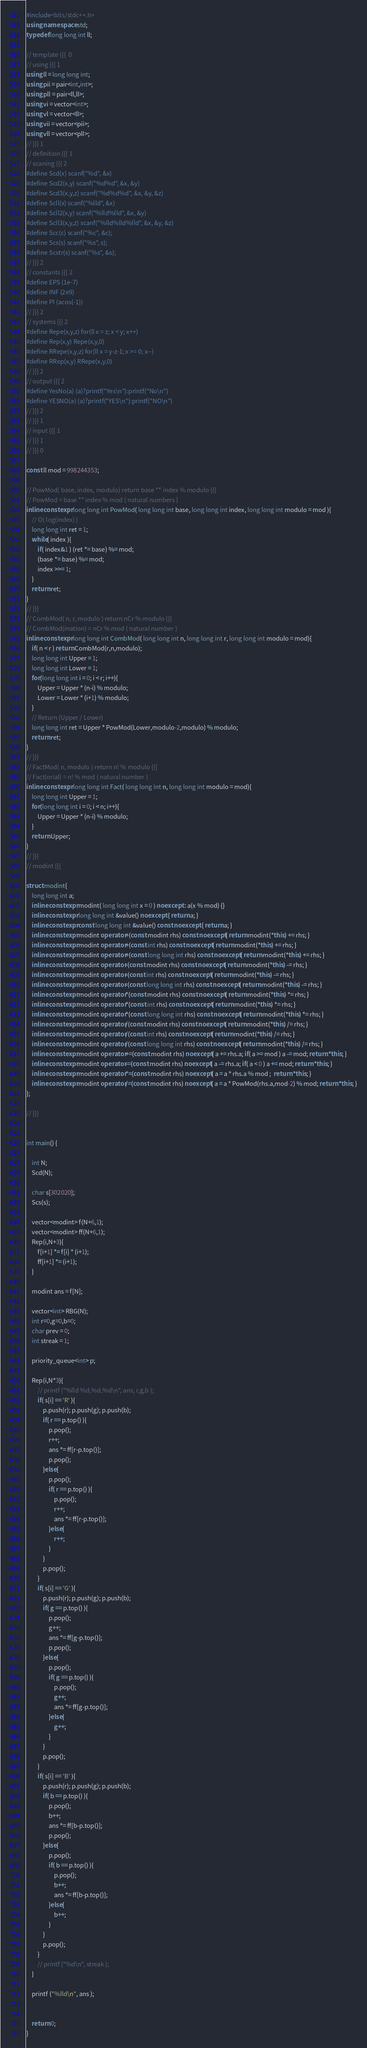Convert code to text. <code><loc_0><loc_0><loc_500><loc_500><_C++_>#include<bits/stdc++.h>
using namespace std;
typedef long long int ll;

// template {{{  0 
// using {{{ 1
using ll = long long int;
using pii = pair<int,int>;
using pll = pair<ll,ll>;
using vi = vector<int>;
using vl = vector<ll>;
using vii = vector<pii>;
using vll = vector<pll>;
// }}} 1
// definition {{{ 1
// scaning {{{ 2
#define Scd(x) scanf("%d", &x)
#define Scd2(x,y) scanf("%d%d", &x, &y)
#define Scd3(x,y,z) scanf("%d%d%d", &x, &y, &z)
#define Scll(x) scanf("%lld", &x)
#define Scll2(x,y) scanf("%lld%lld", &x, &y)
#define Scll3(x,y,z) scanf("%lld%lld%lld", &x, &y, &z)
#define Scc(c) scanf("%c", &c);
#define Scs(s) scanf("%s", s);
#define Scstr(s) scanf("%s", &s);
// }}} 2
// constants {{{ 2
#define EPS (1e-7)
#define INF (2e9)
#define PI (acos(-1))
// }}} 2
// systems {{{ 2
#define Repe(x,y,z) for(ll x = z; x < y; x++)
#define Rep(x,y) Repe(x,y,0)
#define RRepe(x,y,z) for(ll x = y-z-1; x >= 0; x--)
#define RRep(x,y) RRepe(x,y,0)
// }}} 2
// output {{{ 2
#define YesNo(a) (a)?printf("Yes\n"):printf("No\n")
#define YESNO(a) (a)?printf("YES\n"):printf("NO\n")
// }}} 2
// }}} 1
// input {{{ 1
// }}} 1
// }}} 0

const ll mod = 998244353;

// PowMod( base, index, modulo) return base ** index % modulo {{{
// PowMod = base ** index % mod ( natural numbers )
inline constexpr long long int PowMod( long long int base, long long int index, long long int modulo = mod ){
    // O( log(index) )
    long long int ret = 1;
    while( index ){
        if( index&1 ) (ret *= base) %= mod;
        (base *= base) %= mod;
        index >>= 1;
    }
    return ret;
}
// }}}
// CombMod( n, r, modulo ) return nCr % modulo {{{
// CombMod(ination) = nCr % mod ( natural number )
inline constexpr long long int CombMod( long long int n, long long int r, long long int modulo = mod){
    if( n < r ) return CombMod(r,n,modulo);
    long long int Upper = 1;
    long long int Lower = 1;
    for(long long int i = 0; i < r; i++){
        Upper = Upper * (n-i) % modulo;
        Lower = Lower * (i+1) % modulo;
    }
    // Return (Upper / Lower)
    long long int ret = Upper * PowMod(Lower,modulo-2,modulo) % modulo;
    return ret;
}
// }}}
// FactMod( n, modulo ) return n! % modulo {{{
// Fact(orial) = n! % mod ( natural number )
inline constexpr long long int Fact( long long int n, long long int modulo = mod){
    long long int Upper = 1;
    for(long long int i = 0; i < n; i++){
        Upper = Upper * (n-i) % modulo;
    }
    return Upper;
}
// }}}
// modint {{{

struct modint{
    long long int a;
    inline constexpr modint( long long int x = 0 ) noexcept : a(x % mod) {}
    inline constexpr long long int &value() noexcept { return a; }
    inline constexpr const long long int &value() const noexcept { return a; }
    inline constexpr modint operator+(const modint rhs) const noexcept{ return modint(*this) += rhs; }
    inline constexpr modint operator+(const int rhs) const noexcept{ return modint(*this) += rhs; }
    inline constexpr modint operator+(const long long int rhs) const noexcept{ return modint(*this) += rhs; }
    inline constexpr modint operator-(const modint rhs) const noexcept{ return modint(*this) -= rhs; }
    inline constexpr modint operator-(const int rhs) const noexcept{ return modint(*this) -= rhs; }
    inline constexpr modint operator-(const long long int rhs) const noexcept{ return modint(*this) -= rhs; }
    inline constexpr modint operator*(const modint rhs) const noexcept{ return modint(*this) *= rhs; }
    inline constexpr modint operator*(const int rhs) const noexcept{ return modint(*this) *= rhs; }
    inline constexpr modint operator*(const long long int rhs) const noexcept{ return modint(*this) *= rhs; }
    inline constexpr modint operator/(const modint rhs) const noexcept{ return modint(*this) /= rhs; }
    inline constexpr modint operator/(const int rhs) const noexcept{ return modint(*this) /= rhs; }
    inline constexpr modint operator/(const long long int rhs) const noexcept{ return modint(*this) /= rhs; }
    inline constexpr modint operator+=(const modint rhs) noexcept{ a += rhs.a; if( a >= mod ) a -= mod; return *this; }
    inline constexpr modint operator-=(const modint rhs) noexcept{ a -= rhs.a; if( a < 0 ) a += mod; return *this; }
    inline constexpr modint operator*=(const modint rhs) noexcept{ a = a * rhs.a % mod ;  return *this; }
    inline constexpr modint operator/=(const modint rhs) noexcept{ a = a * PowMod(rhs.a,mod-2) % mod; return *this; }
};

// }}}


int main() {

    int N;
    Scd(N);

    char s[302020];
    Scs(s);

    vector<modint> f(N+6,1);
    vector<modint> ff(N+6,1);
    Rep(i,N+3){
        f[i+1] *= f[i] * (i+1);
        ff[i+1] *= (i+1);
    }

    modint ans = f[N];

    vector<int> RBG(N);
    int r=0,g=0,b=0;
    char prev = 0;
    int streak = 1;

    priority_queue<int> p;

    Rep(i,N*3){
        // printf ("%lld %d,%d,%d\n", ans, r,g,b );
        if( s[i] == 'R' ){
            p.push(r); p.push(g); p.push(b);
            if( r == p.top() ){
                p.pop();
                r++;
                ans *= ff[r-p.top()];
                p.pop();
            }else{
                p.pop();
                if( r == p.top() ){
                    p.pop();
                    r++;
                    ans *= ff[r-p.top()];
                }else{
                    r++;
                }
            }
            p.pop();
        }
        if( s[i] == 'G' ){
            p.push(r); p.push(g); p.push(b);
            if( g == p.top() ){
                p.pop();
                g++;
                ans *= ff[g-p.top()];
                p.pop();
            }else{
                p.pop();
                if( g == p.top() ){
                    p.pop();
                    g++;
                    ans *= ff[g-p.top()];
                }else{
                    g++;
                }
            }
            p.pop();
        }
        if( s[i] == 'B' ){
            p.push(r); p.push(g); p.push(b);
            if( b == p.top() ){
                p.pop();
                b++;
                ans *= ff[b-p.top()];
                p.pop();
            }else{
                p.pop();
                if( b == p.top() ){
                    p.pop();
                    b++;
                    ans *= ff[b-p.top()];
                }else{
                    b++;
                }
            }
            p.pop();
        }
        // printf ("%d\n", streak );
    }

    printf ("%lld\n", ans );


    return 0;
}

</code> 